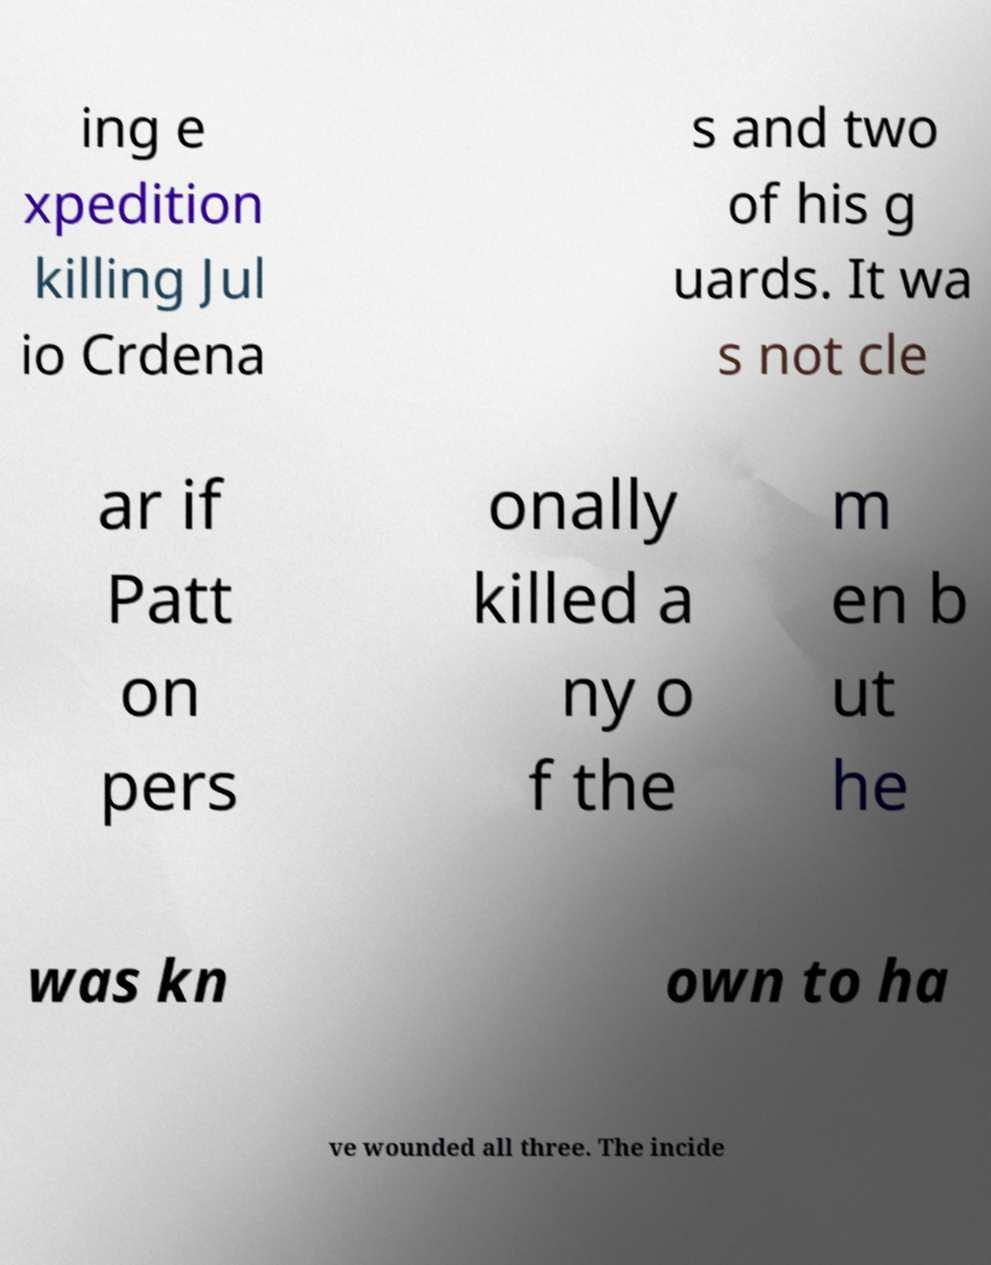There's text embedded in this image that I need extracted. Can you transcribe it verbatim? ing e xpedition killing Jul io Crdena s and two of his g uards. It wa s not cle ar if Patt on pers onally killed a ny o f the m en b ut he was kn own to ha ve wounded all three. The incide 